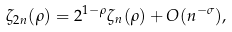<formula> <loc_0><loc_0><loc_500><loc_500>\zeta _ { 2 n } ( \rho ) = 2 ^ { 1 - \rho } \zeta _ { n } ( \rho ) + O ( n ^ { - \sigma } ) ,</formula> 